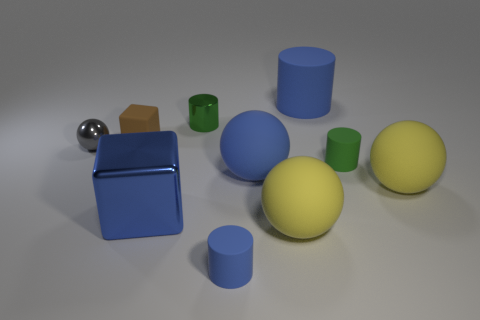Is the number of brown cubes in front of the brown object less than the number of matte balls behind the blue shiny thing?
Offer a terse response. Yes. There is a big blue matte thing that is behind the small green metallic thing; is it the same shape as the small green rubber object?
Your answer should be compact. Yes. Are there any other things that have the same material as the small gray object?
Provide a short and direct response. Yes. Are the small green object that is behind the tiny ball and the big blue cylinder made of the same material?
Your answer should be compact. No. What material is the blue cylinder behind the green object right of the blue cylinder to the left of the large blue ball?
Provide a succinct answer. Rubber. What number of other things are there of the same shape as the green metallic thing?
Provide a short and direct response. 3. What color is the tiny cylinder right of the large matte cylinder?
Offer a terse response. Green. There is a tiny green cylinder on the right side of the blue rubber cylinder that is behind the gray thing; how many small green cylinders are left of it?
Offer a very short reply. 1. How many yellow matte things are left of the blue cylinder that is behind the tiny blue cylinder?
Keep it short and to the point. 1. There is a tiny gray thing; what number of blue rubber cylinders are to the right of it?
Provide a succinct answer. 2. 